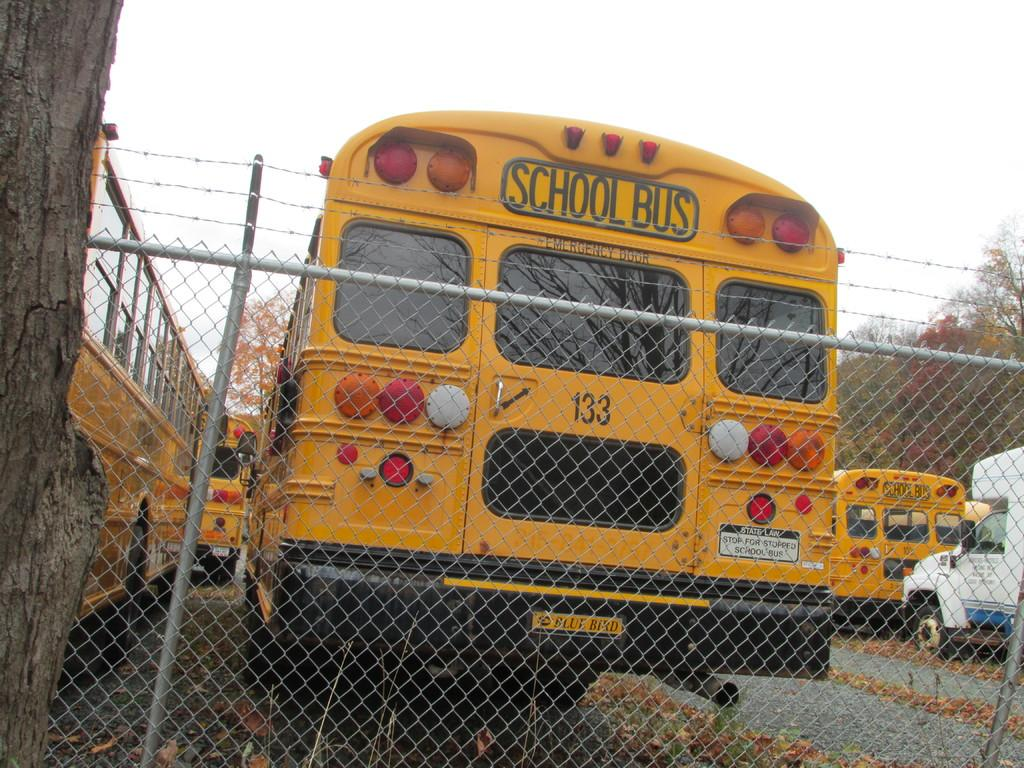<image>
Summarize the visual content of the image. the back of a school bus with 133 is shown 